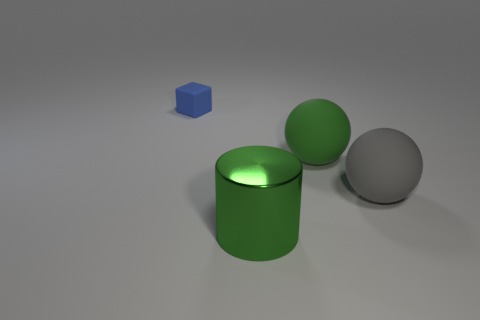What number of other things are the same material as the tiny block?
Ensure brevity in your answer.  2. How many objects are either big green things in front of the large gray rubber sphere or things that are to the right of the tiny matte object?
Offer a terse response. 3. There is a large green object behind the big metallic cylinder; is it the same shape as the rubber object behind the large green ball?
Your response must be concise. No. There is a green matte object that is the same size as the green cylinder; what is its shape?
Provide a succinct answer. Sphere. How many metal objects are either large green cylinders or small purple cylinders?
Your answer should be very brief. 1. Do the green thing behind the large shiny object and the thing that is on the left side of the green shiny thing have the same material?
Provide a succinct answer. Yes. What is the color of the small cube that is the same material as the big gray thing?
Your response must be concise. Blue. Are there more things left of the small blue object than big gray matte objects in front of the metal thing?
Your response must be concise. No. Are any small brown metal cubes visible?
Your answer should be compact. No. There is a large thing that is the same color as the cylinder; what is its material?
Your response must be concise. Rubber. 